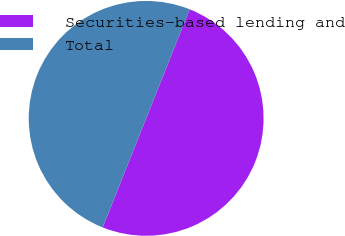Convert chart. <chart><loc_0><loc_0><loc_500><loc_500><pie_chart><fcel>Securities-based lending and<fcel>Total<nl><fcel>50.0%<fcel>50.0%<nl></chart> 